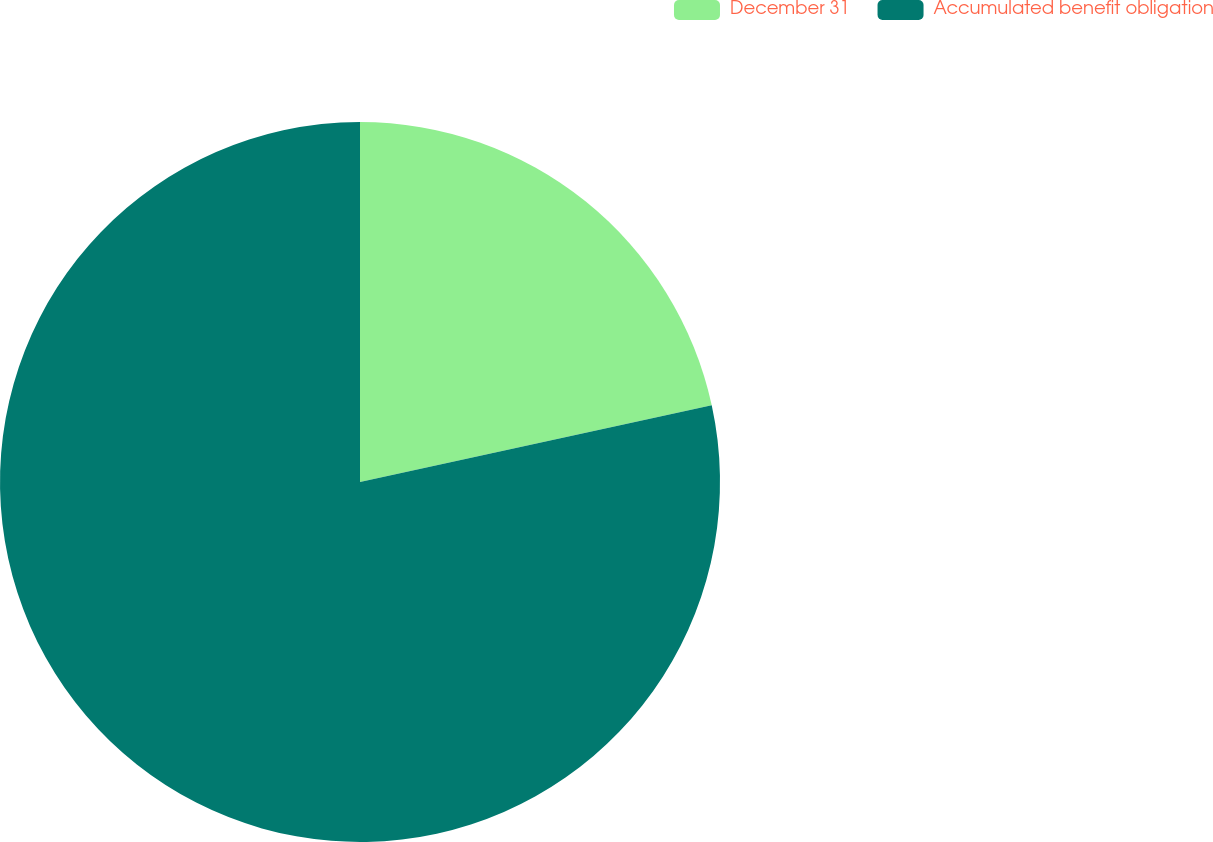<chart> <loc_0><loc_0><loc_500><loc_500><pie_chart><fcel>December 31<fcel>Accumulated benefit obligation<nl><fcel>21.58%<fcel>78.42%<nl></chart> 